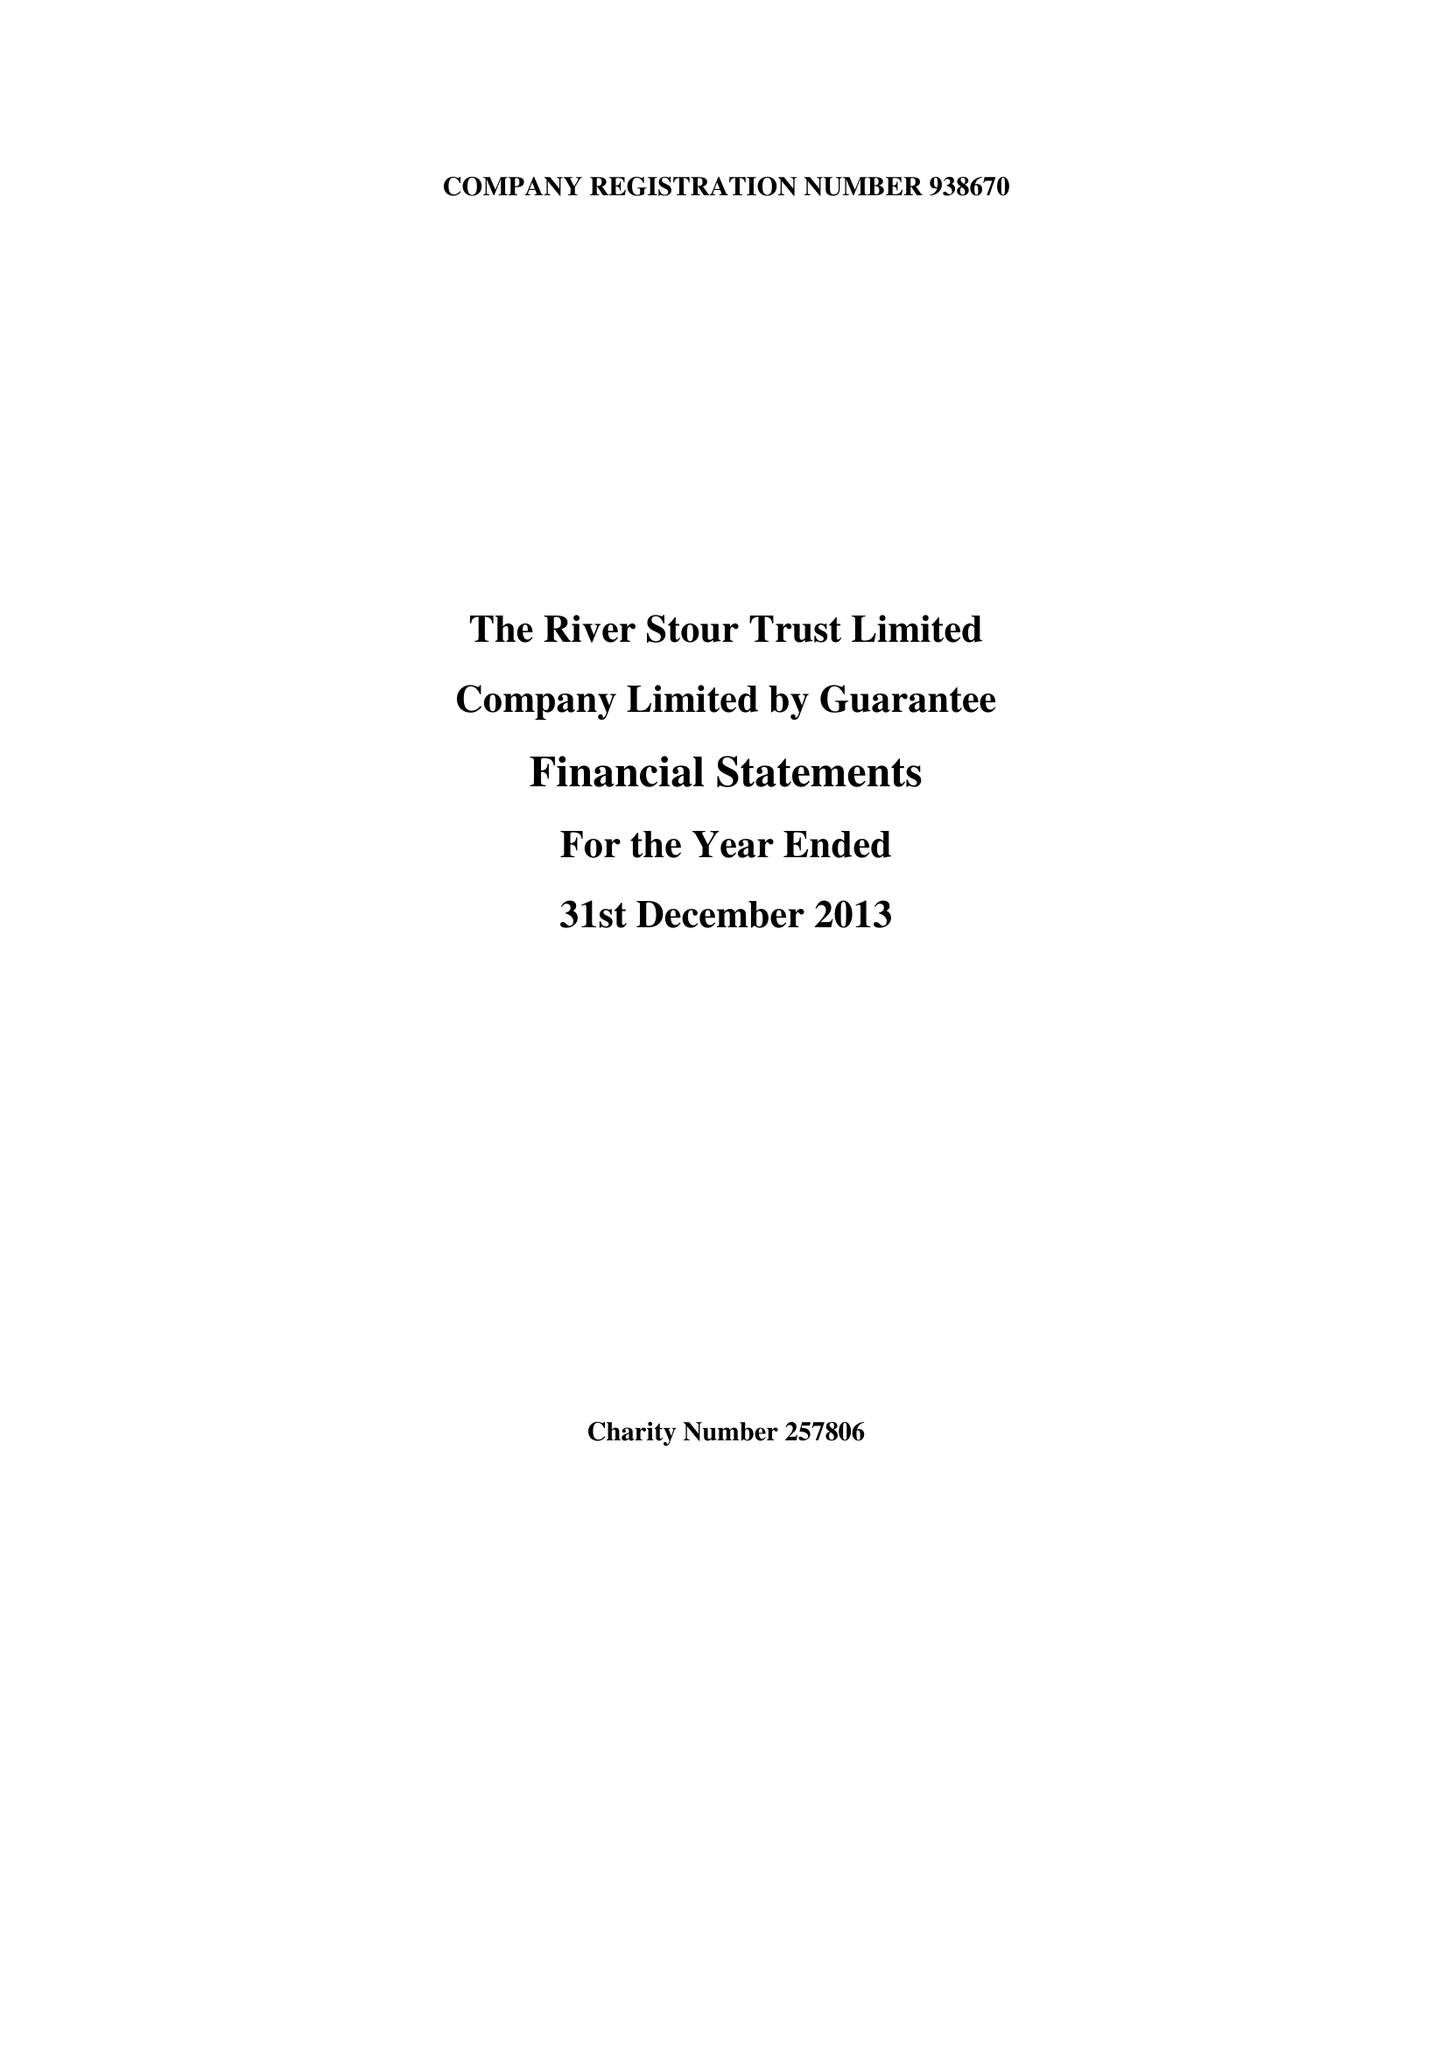What is the value for the address__street_line?
Answer the question using a single word or phrase. None 